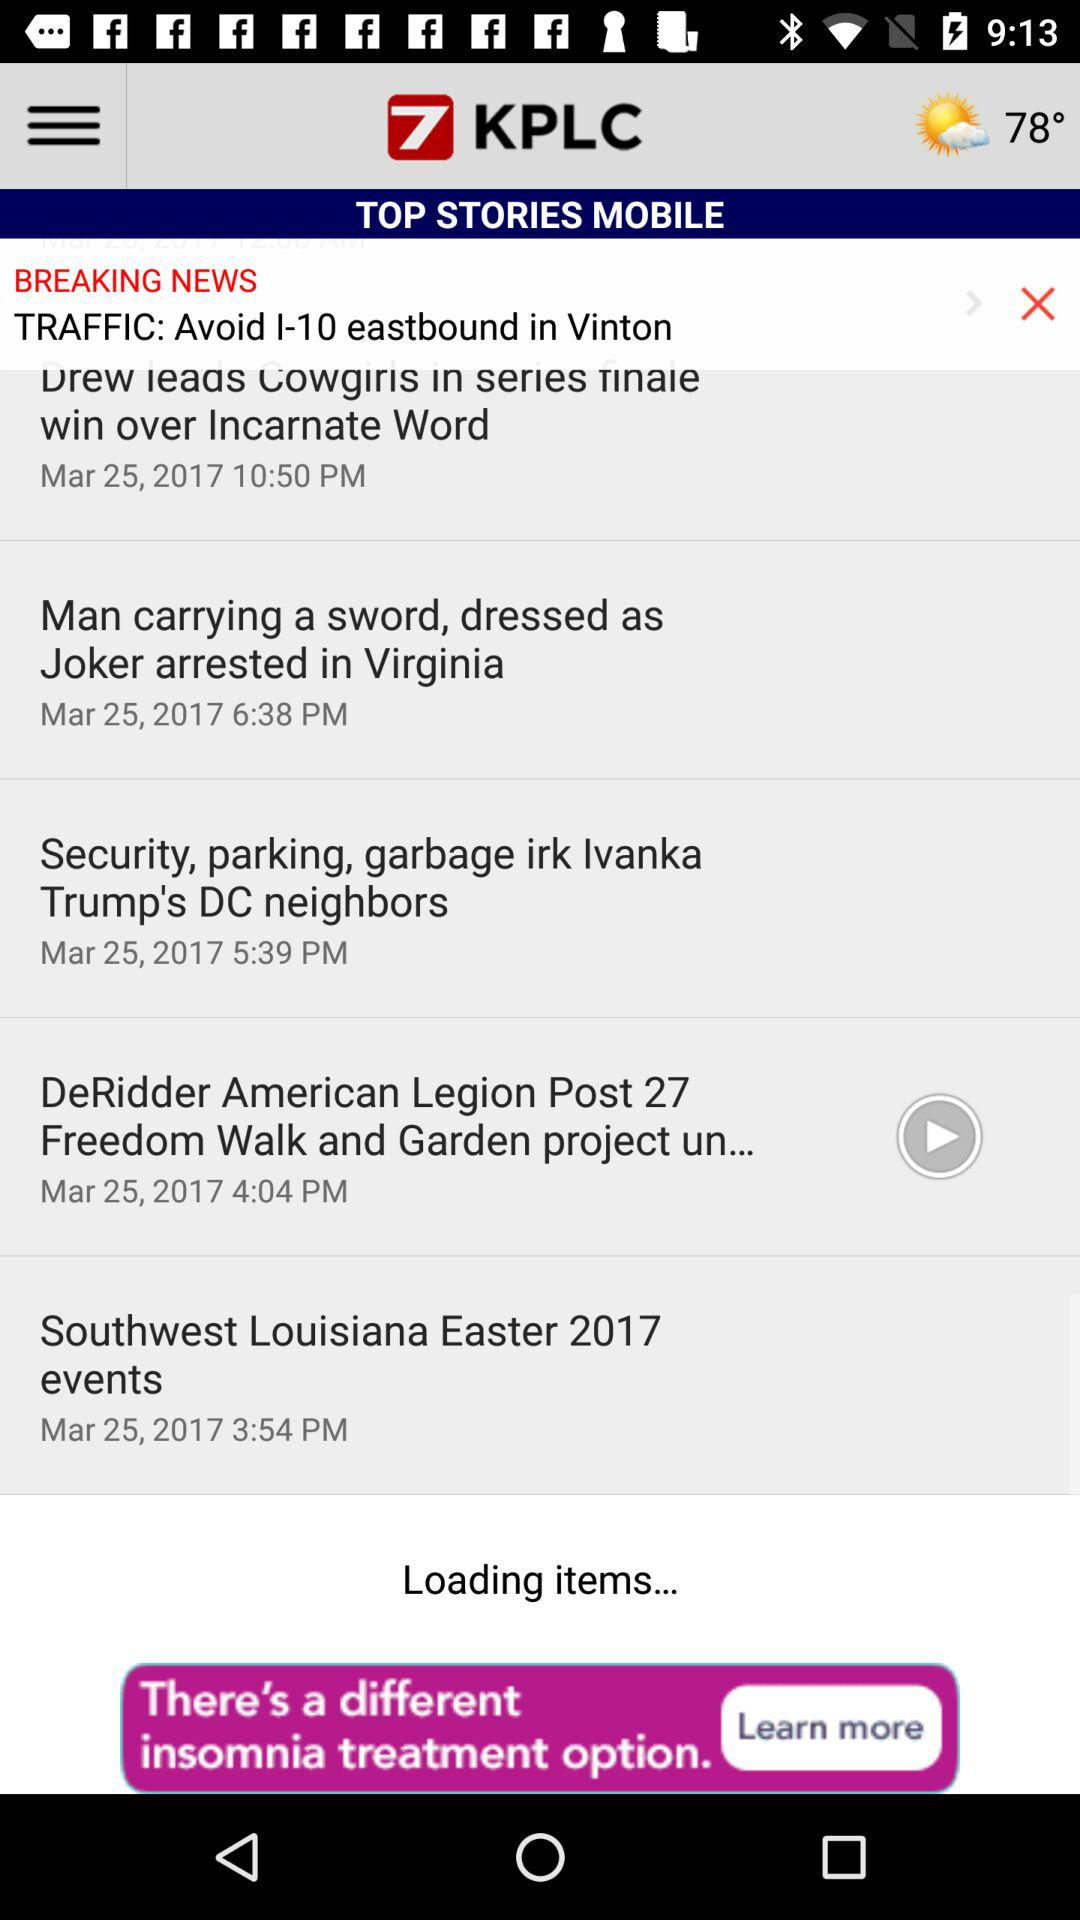What is the name of the application? The name of the application is "KPLC". 